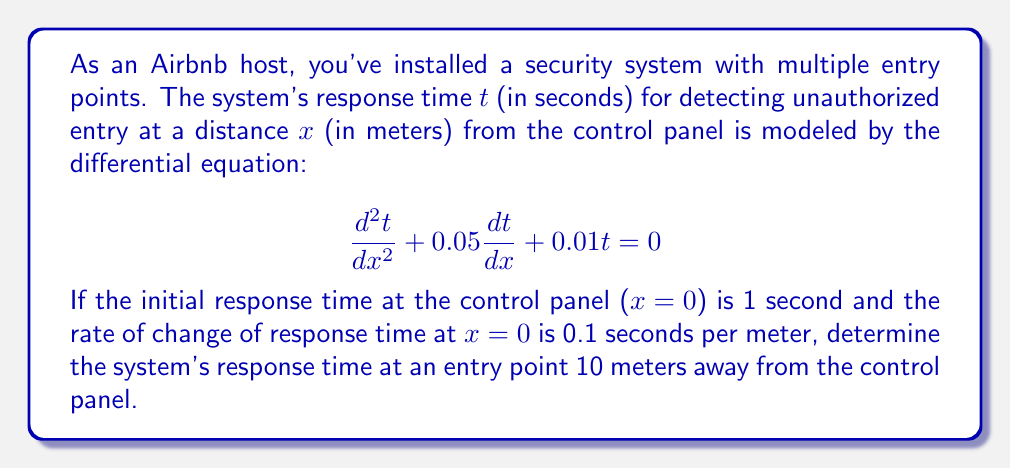Can you answer this question? To solve this problem, we need to follow these steps:

1) First, we identify this as a second-order linear homogeneous differential equation with constant coefficients.

2) The characteristic equation for this differential equation is:
   $$r^2 + 0.05r + 0.01 = 0$$

3) Solving this quadratic equation:
   $$r = \frac{-0.05 \pm \sqrt{0.05^2 - 4(1)(0.01)}}{2(1)} = \frac{-0.05 \pm \sqrt{0.0025 - 0.04}}{2} = \frac{-0.05 \pm \sqrt{-0.0375}}{2}$$

4) This gives us complex roots:
   $$r_1 = -0.025 + 0.096i$$
   $$r_2 = -0.025 - 0.096i$$

5) The general solution is therefore:
   $$t(x) = e^{-0.025x}(C_1\cos(0.096x) + C_2\sin(0.096x))$$

6) Now we use the initial conditions to find $C_1$ and $C_2$:
   At $x=0$, $t=1$: $1 = C_1$
   At $x=0$, $\frac{dt}{dx}=0.1$: $0.1 = -0.025C_1 + 0.096C_2$

7) From these, we get:
   $C_1 = 1$
   $C_2 = 1.3021$

8) Our particular solution is:
   $$t(x) = e^{-0.025x}(\cos(0.096x) + 1.3021\sin(0.096x))$$

9) To find the response time at 10 meters, we evaluate $t(10)$:
   $$t(10) = e^{-0.25}(\cos(0.96) + 1.3021\sin(0.96))$$

10) Calculating this gives us approximately 0.9733 seconds.
Answer: The security system's response time at an entry point 10 meters away from the control panel is approximately 0.9733 seconds. 